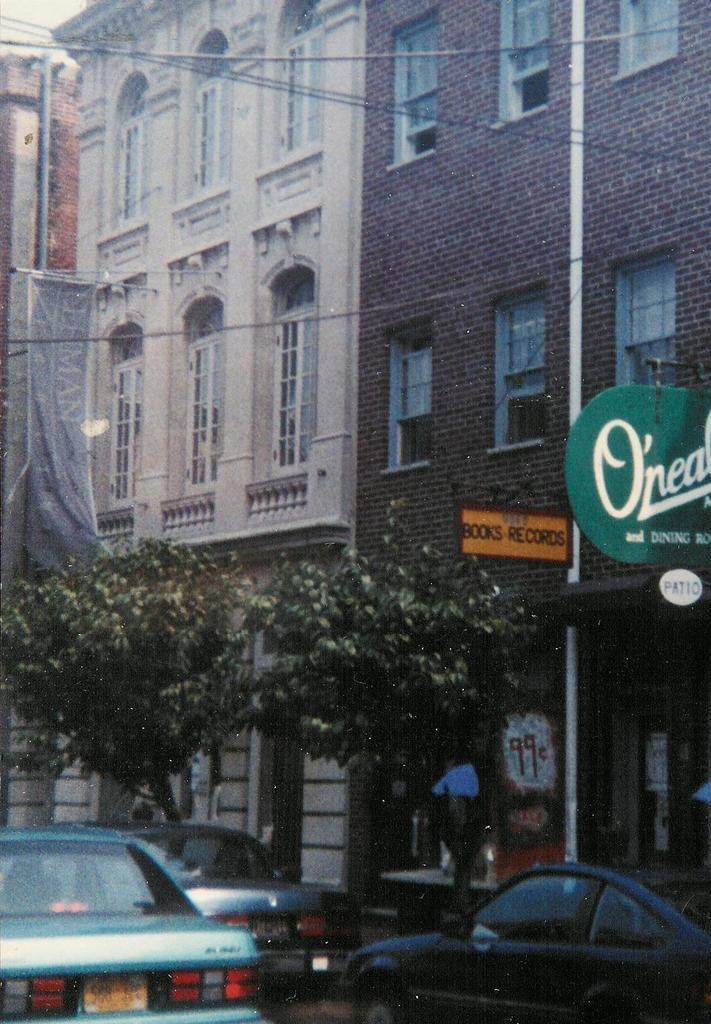How would you summarize this image in a sentence or two? There are trees and cars at the bottom of this image, and we can see buildings in the background. 